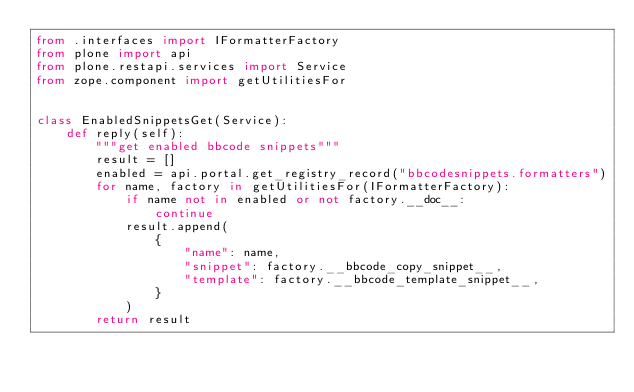Convert code to text. <code><loc_0><loc_0><loc_500><loc_500><_Python_>from .interfaces import IFormatterFactory
from plone import api
from plone.restapi.services import Service
from zope.component import getUtilitiesFor


class EnabledSnippetsGet(Service):
    def reply(self):
        """get enabled bbcode snippets"""
        result = []
        enabled = api.portal.get_registry_record("bbcodesnippets.formatters")
        for name, factory in getUtilitiesFor(IFormatterFactory):
            if name not in enabled or not factory.__doc__:
                continue
            result.append(
                {
                    "name": name,
                    "snippet": factory.__bbcode_copy_snippet__,
                    "template": factory.__bbcode_template_snippet__,
                }
            )
        return result
</code> 